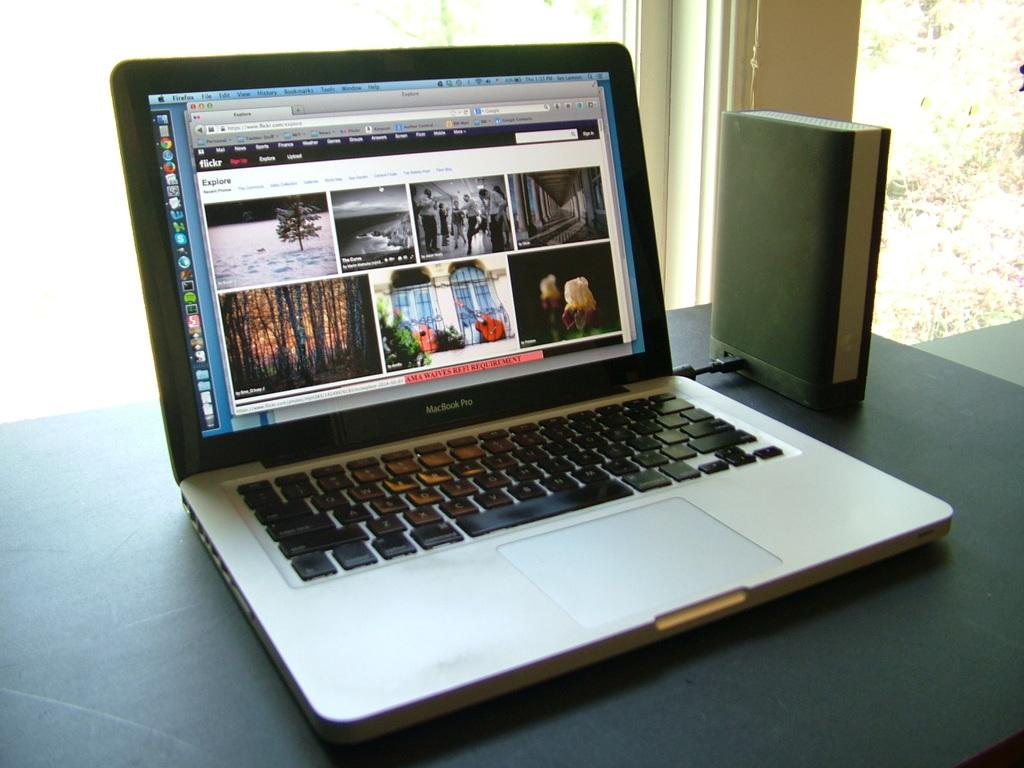<image>
Relay a brief, clear account of the picture shown. an open macbook pro laptop on a black table top 